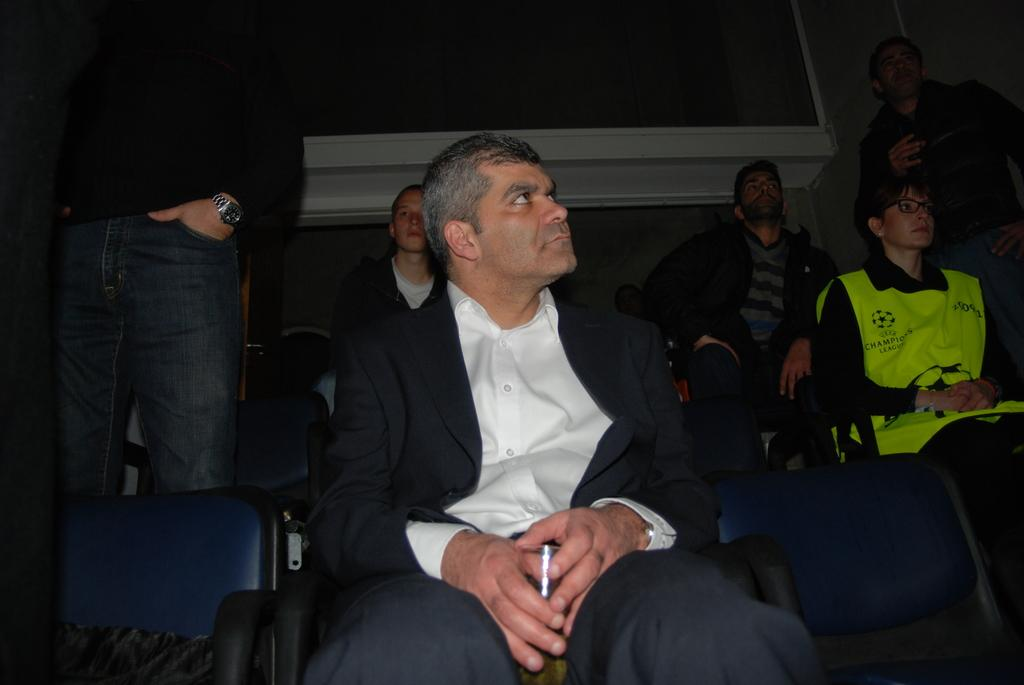What are the people in the image doing? The people in the image are sitting in chairs. Are there any people standing in the image? Yes, there is a person standing on the right side of the image and another person standing on the left side of the image. What can be seen at the top of the image? There is a window-like object at the top of the image. What color is the orange that is being peeled by the person on the left side of the image? There is no orange present in the image; the person on the left side of the image is standing, not peeling an orange. 